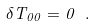Convert formula to latex. <formula><loc_0><loc_0><loc_500><loc_500>\delta T _ { 0 0 } = 0 \ .</formula> 